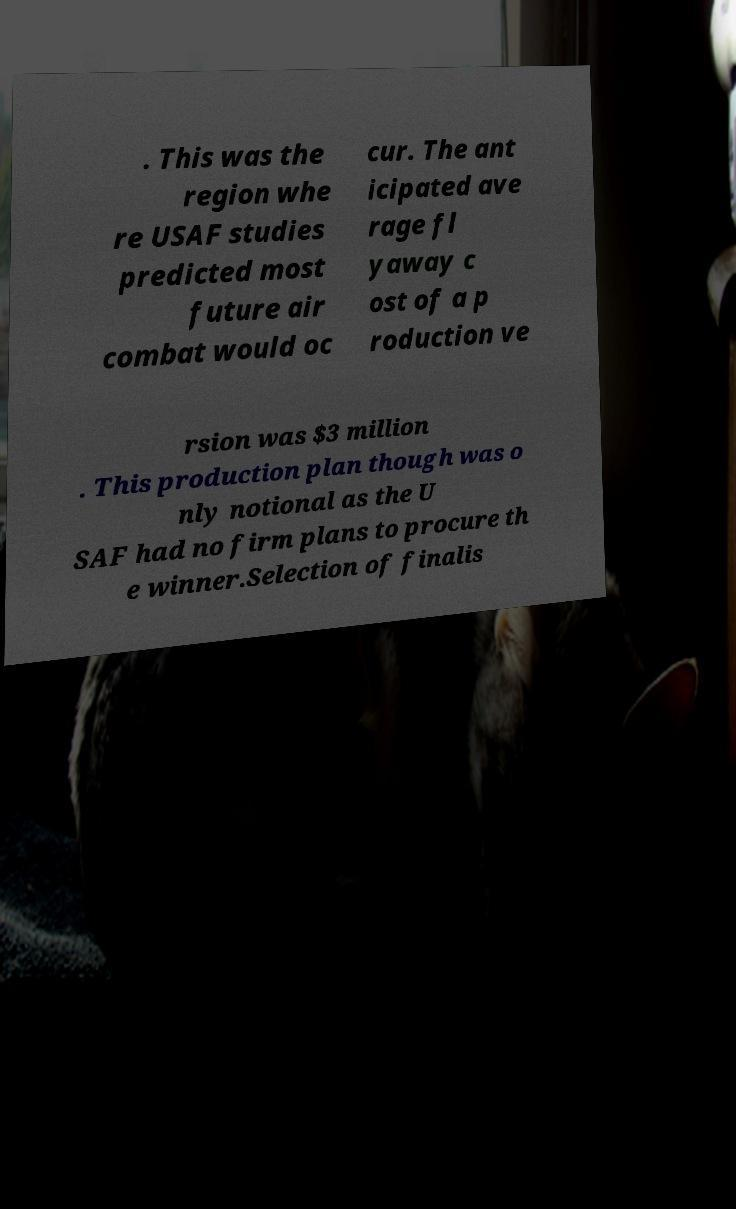Please identify and transcribe the text found in this image. . This was the region whe re USAF studies predicted most future air combat would oc cur. The ant icipated ave rage fl yaway c ost of a p roduction ve rsion was $3 million . This production plan though was o nly notional as the U SAF had no firm plans to procure th e winner.Selection of finalis 